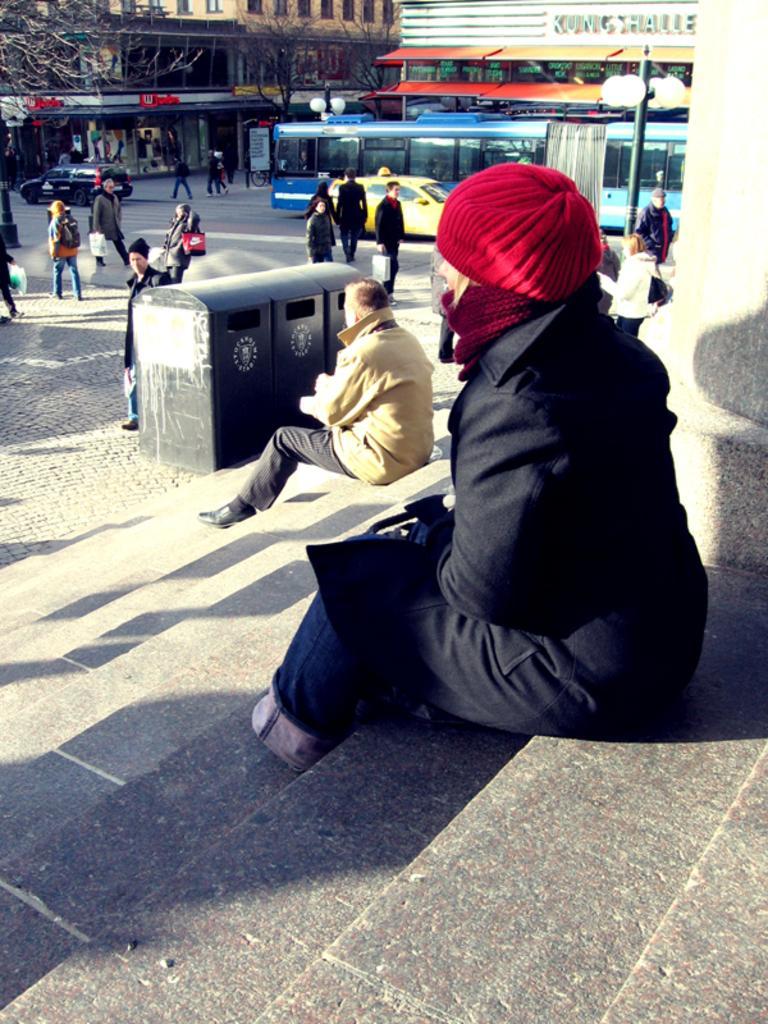In one or two sentences, can you explain what this image depicts? In the foreground I can see two persons are sitting on the steps. In the background I can see a crowd and vehicles on the road. At the top I can see buildings and trees. This image is taken during a sunny day. 